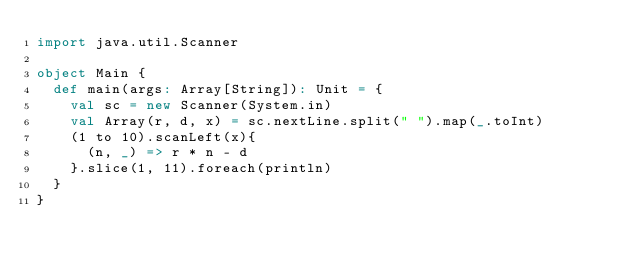<code> <loc_0><loc_0><loc_500><loc_500><_Scala_>import java.util.Scanner

object Main {
  def main(args: Array[String]): Unit = {
    val sc = new Scanner(System.in)
    val Array(r, d, x) = sc.nextLine.split(" ").map(_.toInt)
    (1 to 10).scanLeft(x){
      (n, _) => r * n - d
    }.slice(1, 11).foreach(println)
  }
}
</code> 